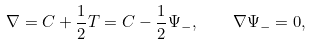<formula> <loc_0><loc_0><loc_500><loc_500>\nabla = \L C + \frac { 1 } { 2 } T = \L C - \frac { 1 } { 2 } \Psi _ { - } , \quad \nabla \Psi _ { - } = 0 ,</formula> 